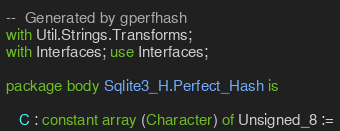Convert code to text. <code><loc_0><loc_0><loc_500><loc_500><_Ada_>--  Generated by gperfhash
with Util.Strings.Transforms;
with Interfaces; use Interfaces;

package body Sqlite3_H.Perfect_Hash is

   C : constant array (Character) of Unsigned_8 :=</code> 